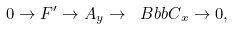Convert formula to latex. <formula><loc_0><loc_0><loc_500><loc_500>0 \to F ^ { \prime } \to A _ { y } \to { \ B b b C } _ { x } \to 0 ,</formula> 